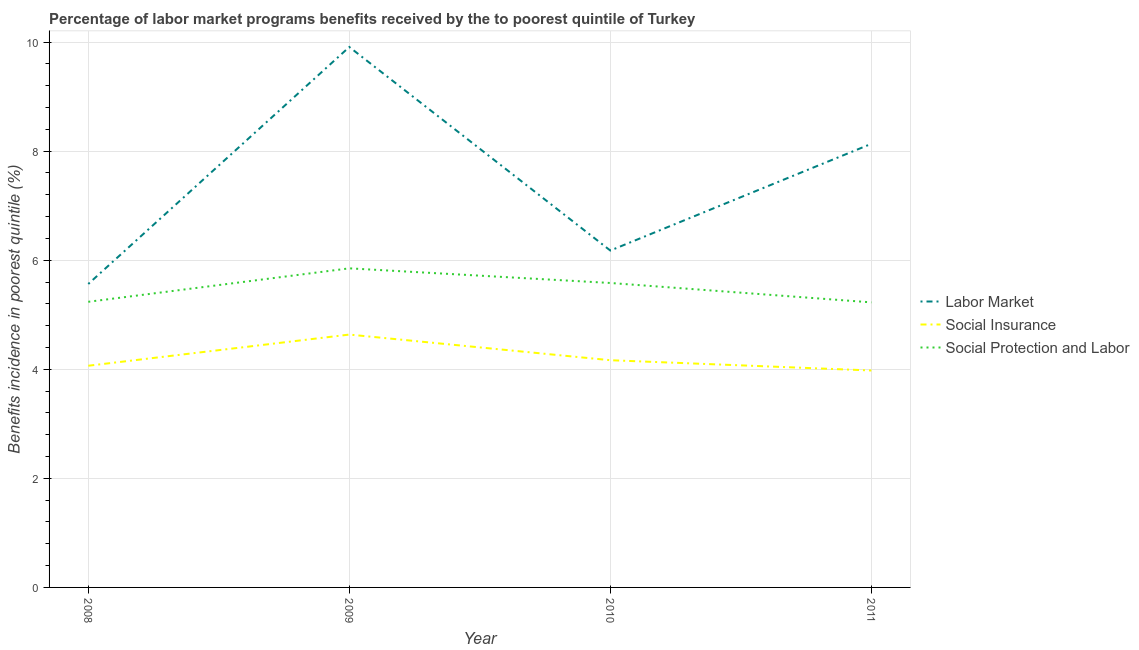What is the percentage of benefits received due to labor market programs in 2011?
Your response must be concise. 8.13. Across all years, what is the maximum percentage of benefits received due to labor market programs?
Ensure brevity in your answer.  9.91. Across all years, what is the minimum percentage of benefits received due to labor market programs?
Offer a very short reply. 5.56. In which year was the percentage of benefits received due to social protection programs minimum?
Keep it short and to the point. 2011. What is the total percentage of benefits received due to social insurance programs in the graph?
Your response must be concise. 16.84. What is the difference between the percentage of benefits received due to social protection programs in 2008 and that in 2010?
Ensure brevity in your answer.  -0.35. What is the difference between the percentage of benefits received due to social protection programs in 2010 and the percentage of benefits received due to labor market programs in 2009?
Keep it short and to the point. -4.33. What is the average percentage of benefits received due to social insurance programs per year?
Offer a very short reply. 4.21. In the year 2008, what is the difference between the percentage of benefits received due to social insurance programs and percentage of benefits received due to social protection programs?
Give a very brief answer. -1.17. In how many years, is the percentage of benefits received due to labor market programs greater than 2 %?
Provide a succinct answer. 4. What is the ratio of the percentage of benefits received due to social insurance programs in 2008 to that in 2009?
Your answer should be very brief. 0.88. Is the percentage of benefits received due to labor market programs in 2009 less than that in 2011?
Your answer should be compact. No. Is the difference between the percentage of benefits received due to social insurance programs in 2010 and 2011 greater than the difference between the percentage of benefits received due to social protection programs in 2010 and 2011?
Give a very brief answer. No. What is the difference between the highest and the second highest percentage of benefits received due to labor market programs?
Provide a short and direct response. 1.78. What is the difference between the highest and the lowest percentage of benefits received due to social insurance programs?
Provide a short and direct response. 0.66. In how many years, is the percentage of benefits received due to social insurance programs greater than the average percentage of benefits received due to social insurance programs taken over all years?
Ensure brevity in your answer.  1. Is the sum of the percentage of benefits received due to labor market programs in 2008 and 2011 greater than the maximum percentage of benefits received due to social insurance programs across all years?
Your answer should be compact. Yes. Does the percentage of benefits received due to labor market programs monotonically increase over the years?
Your answer should be very brief. No. Is the percentage of benefits received due to social protection programs strictly greater than the percentage of benefits received due to social insurance programs over the years?
Keep it short and to the point. Yes. How many years are there in the graph?
Provide a succinct answer. 4. What is the difference between two consecutive major ticks on the Y-axis?
Provide a short and direct response. 2. Are the values on the major ticks of Y-axis written in scientific E-notation?
Your response must be concise. No. Does the graph contain any zero values?
Your answer should be very brief. No. Does the graph contain grids?
Your answer should be compact. Yes. Where does the legend appear in the graph?
Your response must be concise. Center right. How many legend labels are there?
Your answer should be very brief. 3. What is the title of the graph?
Give a very brief answer. Percentage of labor market programs benefits received by the to poorest quintile of Turkey. What is the label or title of the X-axis?
Provide a succinct answer. Year. What is the label or title of the Y-axis?
Provide a short and direct response. Benefits incidence in poorest quintile (%). What is the Benefits incidence in poorest quintile (%) of Labor Market in 2008?
Keep it short and to the point. 5.56. What is the Benefits incidence in poorest quintile (%) of Social Insurance in 2008?
Give a very brief answer. 4.06. What is the Benefits incidence in poorest quintile (%) of Social Protection and Labor in 2008?
Make the answer very short. 5.24. What is the Benefits incidence in poorest quintile (%) of Labor Market in 2009?
Provide a succinct answer. 9.91. What is the Benefits incidence in poorest quintile (%) of Social Insurance in 2009?
Your answer should be compact. 4.64. What is the Benefits incidence in poorest quintile (%) of Social Protection and Labor in 2009?
Your answer should be compact. 5.85. What is the Benefits incidence in poorest quintile (%) in Labor Market in 2010?
Keep it short and to the point. 6.18. What is the Benefits incidence in poorest quintile (%) of Social Insurance in 2010?
Keep it short and to the point. 4.17. What is the Benefits incidence in poorest quintile (%) in Social Protection and Labor in 2010?
Ensure brevity in your answer.  5.58. What is the Benefits incidence in poorest quintile (%) of Labor Market in 2011?
Make the answer very short. 8.13. What is the Benefits incidence in poorest quintile (%) in Social Insurance in 2011?
Give a very brief answer. 3.98. What is the Benefits incidence in poorest quintile (%) of Social Protection and Labor in 2011?
Make the answer very short. 5.23. Across all years, what is the maximum Benefits incidence in poorest quintile (%) in Labor Market?
Offer a terse response. 9.91. Across all years, what is the maximum Benefits incidence in poorest quintile (%) in Social Insurance?
Your answer should be very brief. 4.64. Across all years, what is the maximum Benefits incidence in poorest quintile (%) of Social Protection and Labor?
Your answer should be very brief. 5.85. Across all years, what is the minimum Benefits incidence in poorest quintile (%) of Labor Market?
Your response must be concise. 5.56. Across all years, what is the minimum Benefits incidence in poorest quintile (%) of Social Insurance?
Offer a very short reply. 3.98. Across all years, what is the minimum Benefits incidence in poorest quintile (%) of Social Protection and Labor?
Provide a short and direct response. 5.23. What is the total Benefits incidence in poorest quintile (%) of Labor Market in the graph?
Provide a succinct answer. 29.78. What is the total Benefits incidence in poorest quintile (%) of Social Insurance in the graph?
Ensure brevity in your answer.  16.84. What is the total Benefits incidence in poorest quintile (%) in Social Protection and Labor in the graph?
Make the answer very short. 21.9. What is the difference between the Benefits incidence in poorest quintile (%) in Labor Market in 2008 and that in 2009?
Offer a terse response. -4.34. What is the difference between the Benefits incidence in poorest quintile (%) in Social Insurance in 2008 and that in 2009?
Provide a succinct answer. -0.57. What is the difference between the Benefits incidence in poorest quintile (%) of Social Protection and Labor in 2008 and that in 2009?
Your answer should be compact. -0.61. What is the difference between the Benefits incidence in poorest quintile (%) of Labor Market in 2008 and that in 2010?
Your answer should be compact. -0.61. What is the difference between the Benefits incidence in poorest quintile (%) of Social Insurance in 2008 and that in 2010?
Your answer should be compact. -0.1. What is the difference between the Benefits incidence in poorest quintile (%) in Social Protection and Labor in 2008 and that in 2010?
Provide a succinct answer. -0.34. What is the difference between the Benefits incidence in poorest quintile (%) in Labor Market in 2008 and that in 2011?
Provide a short and direct response. -2.57. What is the difference between the Benefits incidence in poorest quintile (%) of Social Insurance in 2008 and that in 2011?
Offer a terse response. 0.09. What is the difference between the Benefits incidence in poorest quintile (%) in Social Protection and Labor in 2008 and that in 2011?
Give a very brief answer. 0.01. What is the difference between the Benefits incidence in poorest quintile (%) in Labor Market in 2009 and that in 2010?
Ensure brevity in your answer.  3.73. What is the difference between the Benefits incidence in poorest quintile (%) of Social Insurance in 2009 and that in 2010?
Offer a terse response. 0.47. What is the difference between the Benefits incidence in poorest quintile (%) of Social Protection and Labor in 2009 and that in 2010?
Offer a terse response. 0.27. What is the difference between the Benefits incidence in poorest quintile (%) in Labor Market in 2009 and that in 2011?
Provide a succinct answer. 1.78. What is the difference between the Benefits incidence in poorest quintile (%) of Social Insurance in 2009 and that in 2011?
Your response must be concise. 0.66. What is the difference between the Benefits incidence in poorest quintile (%) in Social Protection and Labor in 2009 and that in 2011?
Offer a very short reply. 0.62. What is the difference between the Benefits incidence in poorest quintile (%) of Labor Market in 2010 and that in 2011?
Keep it short and to the point. -1.96. What is the difference between the Benefits incidence in poorest quintile (%) in Social Insurance in 2010 and that in 2011?
Give a very brief answer. 0.19. What is the difference between the Benefits incidence in poorest quintile (%) in Social Protection and Labor in 2010 and that in 2011?
Your answer should be compact. 0.36. What is the difference between the Benefits incidence in poorest quintile (%) in Labor Market in 2008 and the Benefits incidence in poorest quintile (%) in Social Insurance in 2009?
Keep it short and to the point. 0.93. What is the difference between the Benefits incidence in poorest quintile (%) of Labor Market in 2008 and the Benefits incidence in poorest quintile (%) of Social Protection and Labor in 2009?
Your answer should be compact. -0.29. What is the difference between the Benefits incidence in poorest quintile (%) of Social Insurance in 2008 and the Benefits incidence in poorest quintile (%) of Social Protection and Labor in 2009?
Make the answer very short. -1.79. What is the difference between the Benefits incidence in poorest quintile (%) in Labor Market in 2008 and the Benefits incidence in poorest quintile (%) in Social Insurance in 2010?
Offer a very short reply. 1.4. What is the difference between the Benefits incidence in poorest quintile (%) in Labor Market in 2008 and the Benefits incidence in poorest quintile (%) in Social Protection and Labor in 2010?
Make the answer very short. -0.02. What is the difference between the Benefits incidence in poorest quintile (%) of Social Insurance in 2008 and the Benefits incidence in poorest quintile (%) of Social Protection and Labor in 2010?
Your answer should be very brief. -1.52. What is the difference between the Benefits incidence in poorest quintile (%) of Labor Market in 2008 and the Benefits incidence in poorest quintile (%) of Social Insurance in 2011?
Your answer should be very brief. 1.59. What is the difference between the Benefits incidence in poorest quintile (%) of Labor Market in 2008 and the Benefits incidence in poorest quintile (%) of Social Protection and Labor in 2011?
Give a very brief answer. 0.34. What is the difference between the Benefits incidence in poorest quintile (%) in Social Insurance in 2008 and the Benefits incidence in poorest quintile (%) in Social Protection and Labor in 2011?
Provide a succinct answer. -1.16. What is the difference between the Benefits incidence in poorest quintile (%) in Labor Market in 2009 and the Benefits incidence in poorest quintile (%) in Social Insurance in 2010?
Ensure brevity in your answer.  5.74. What is the difference between the Benefits incidence in poorest quintile (%) in Labor Market in 2009 and the Benefits incidence in poorest quintile (%) in Social Protection and Labor in 2010?
Provide a succinct answer. 4.33. What is the difference between the Benefits incidence in poorest quintile (%) in Social Insurance in 2009 and the Benefits incidence in poorest quintile (%) in Social Protection and Labor in 2010?
Your answer should be compact. -0.95. What is the difference between the Benefits incidence in poorest quintile (%) of Labor Market in 2009 and the Benefits incidence in poorest quintile (%) of Social Insurance in 2011?
Keep it short and to the point. 5.93. What is the difference between the Benefits incidence in poorest quintile (%) in Labor Market in 2009 and the Benefits incidence in poorest quintile (%) in Social Protection and Labor in 2011?
Ensure brevity in your answer.  4.68. What is the difference between the Benefits incidence in poorest quintile (%) of Social Insurance in 2009 and the Benefits incidence in poorest quintile (%) of Social Protection and Labor in 2011?
Offer a very short reply. -0.59. What is the difference between the Benefits incidence in poorest quintile (%) in Labor Market in 2010 and the Benefits incidence in poorest quintile (%) in Social Insurance in 2011?
Your answer should be very brief. 2.2. What is the difference between the Benefits incidence in poorest quintile (%) in Labor Market in 2010 and the Benefits incidence in poorest quintile (%) in Social Protection and Labor in 2011?
Your answer should be compact. 0.95. What is the difference between the Benefits incidence in poorest quintile (%) in Social Insurance in 2010 and the Benefits incidence in poorest quintile (%) in Social Protection and Labor in 2011?
Provide a short and direct response. -1.06. What is the average Benefits incidence in poorest quintile (%) in Labor Market per year?
Your answer should be very brief. 7.45. What is the average Benefits incidence in poorest quintile (%) in Social Insurance per year?
Provide a short and direct response. 4.21. What is the average Benefits incidence in poorest quintile (%) in Social Protection and Labor per year?
Offer a terse response. 5.47. In the year 2008, what is the difference between the Benefits incidence in poorest quintile (%) in Labor Market and Benefits incidence in poorest quintile (%) in Social Insurance?
Provide a succinct answer. 1.5. In the year 2008, what is the difference between the Benefits incidence in poorest quintile (%) of Labor Market and Benefits incidence in poorest quintile (%) of Social Protection and Labor?
Offer a terse response. 0.33. In the year 2008, what is the difference between the Benefits incidence in poorest quintile (%) of Social Insurance and Benefits incidence in poorest quintile (%) of Social Protection and Labor?
Your answer should be very brief. -1.17. In the year 2009, what is the difference between the Benefits incidence in poorest quintile (%) in Labor Market and Benefits incidence in poorest quintile (%) in Social Insurance?
Your answer should be very brief. 5.27. In the year 2009, what is the difference between the Benefits incidence in poorest quintile (%) in Labor Market and Benefits incidence in poorest quintile (%) in Social Protection and Labor?
Your answer should be compact. 4.06. In the year 2009, what is the difference between the Benefits incidence in poorest quintile (%) in Social Insurance and Benefits incidence in poorest quintile (%) in Social Protection and Labor?
Keep it short and to the point. -1.21. In the year 2010, what is the difference between the Benefits incidence in poorest quintile (%) of Labor Market and Benefits incidence in poorest quintile (%) of Social Insurance?
Ensure brevity in your answer.  2.01. In the year 2010, what is the difference between the Benefits incidence in poorest quintile (%) of Labor Market and Benefits incidence in poorest quintile (%) of Social Protection and Labor?
Provide a succinct answer. 0.59. In the year 2010, what is the difference between the Benefits incidence in poorest quintile (%) of Social Insurance and Benefits incidence in poorest quintile (%) of Social Protection and Labor?
Your answer should be very brief. -1.42. In the year 2011, what is the difference between the Benefits incidence in poorest quintile (%) in Labor Market and Benefits incidence in poorest quintile (%) in Social Insurance?
Give a very brief answer. 4.16. In the year 2011, what is the difference between the Benefits incidence in poorest quintile (%) in Labor Market and Benefits incidence in poorest quintile (%) in Social Protection and Labor?
Offer a terse response. 2.91. In the year 2011, what is the difference between the Benefits incidence in poorest quintile (%) of Social Insurance and Benefits incidence in poorest quintile (%) of Social Protection and Labor?
Provide a short and direct response. -1.25. What is the ratio of the Benefits incidence in poorest quintile (%) of Labor Market in 2008 to that in 2009?
Your response must be concise. 0.56. What is the ratio of the Benefits incidence in poorest quintile (%) in Social Insurance in 2008 to that in 2009?
Your response must be concise. 0.88. What is the ratio of the Benefits incidence in poorest quintile (%) of Social Protection and Labor in 2008 to that in 2009?
Offer a very short reply. 0.9. What is the ratio of the Benefits incidence in poorest quintile (%) in Labor Market in 2008 to that in 2010?
Give a very brief answer. 0.9. What is the ratio of the Benefits incidence in poorest quintile (%) in Social Insurance in 2008 to that in 2010?
Make the answer very short. 0.98. What is the ratio of the Benefits incidence in poorest quintile (%) in Social Protection and Labor in 2008 to that in 2010?
Make the answer very short. 0.94. What is the ratio of the Benefits incidence in poorest quintile (%) of Labor Market in 2008 to that in 2011?
Provide a succinct answer. 0.68. What is the ratio of the Benefits incidence in poorest quintile (%) in Social Insurance in 2008 to that in 2011?
Provide a succinct answer. 1.02. What is the ratio of the Benefits incidence in poorest quintile (%) of Social Protection and Labor in 2008 to that in 2011?
Your answer should be compact. 1. What is the ratio of the Benefits incidence in poorest quintile (%) in Labor Market in 2009 to that in 2010?
Your response must be concise. 1.6. What is the ratio of the Benefits incidence in poorest quintile (%) of Social Insurance in 2009 to that in 2010?
Your answer should be compact. 1.11. What is the ratio of the Benefits incidence in poorest quintile (%) in Social Protection and Labor in 2009 to that in 2010?
Provide a short and direct response. 1.05. What is the ratio of the Benefits incidence in poorest quintile (%) of Labor Market in 2009 to that in 2011?
Offer a terse response. 1.22. What is the ratio of the Benefits incidence in poorest quintile (%) in Social Insurance in 2009 to that in 2011?
Your response must be concise. 1.17. What is the ratio of the Benefits incidence in poorest quintile (%) in Social Protection and Labor in 2009 to that in 2011?
Provide a short and direct response. 1.12. What is the ratio of the Benefits incidence in poorest quintile (%) of Labor Market in 2010 to that in 2011?
Keep it short and to the point. 0.76. What is the ratio of the Benefits incidence in poorest quintile (%) in Social Insurance in 2010 to that in 2011?
Ensure brevity in your answer.  1.05. What is the ratio of the Benefits incidence in poorest quintile (%) of Social Protection and Labor in 2010 to that in 2011?
Keep it short and to the point. 1.07. What is the difference between the highest and the second highest Benefits incidence in poorest quintile (%) of Labor Market?
Ensure brevity in your answer.  1.78. What is the difference between the highest and the second highest Benefits incidence in poorest quintile (%) of Social Insurance?
Your answer should be very brief. 0.47. What is the difference between the highest and the second highest Benefits incidence in poorest quintile (%) in Social Protection and Labor?
Provide a succinct answer. 0.27. What is the difference between the highest and the lowest Benefits incidence in poorest quintile (%) in Labor Market?
Offer a terse response. 4.34. What is the difference between the highest and the lowest Benefits incidence in poorest quintile (%) in Social Insurance?
Provide a succinct answer. 0.66. What is the difference between the highest and the lowest Benefits incidence in poorest quintile (%) in Social Protection and Labor?
Your answer should be very brief. 0.62. 